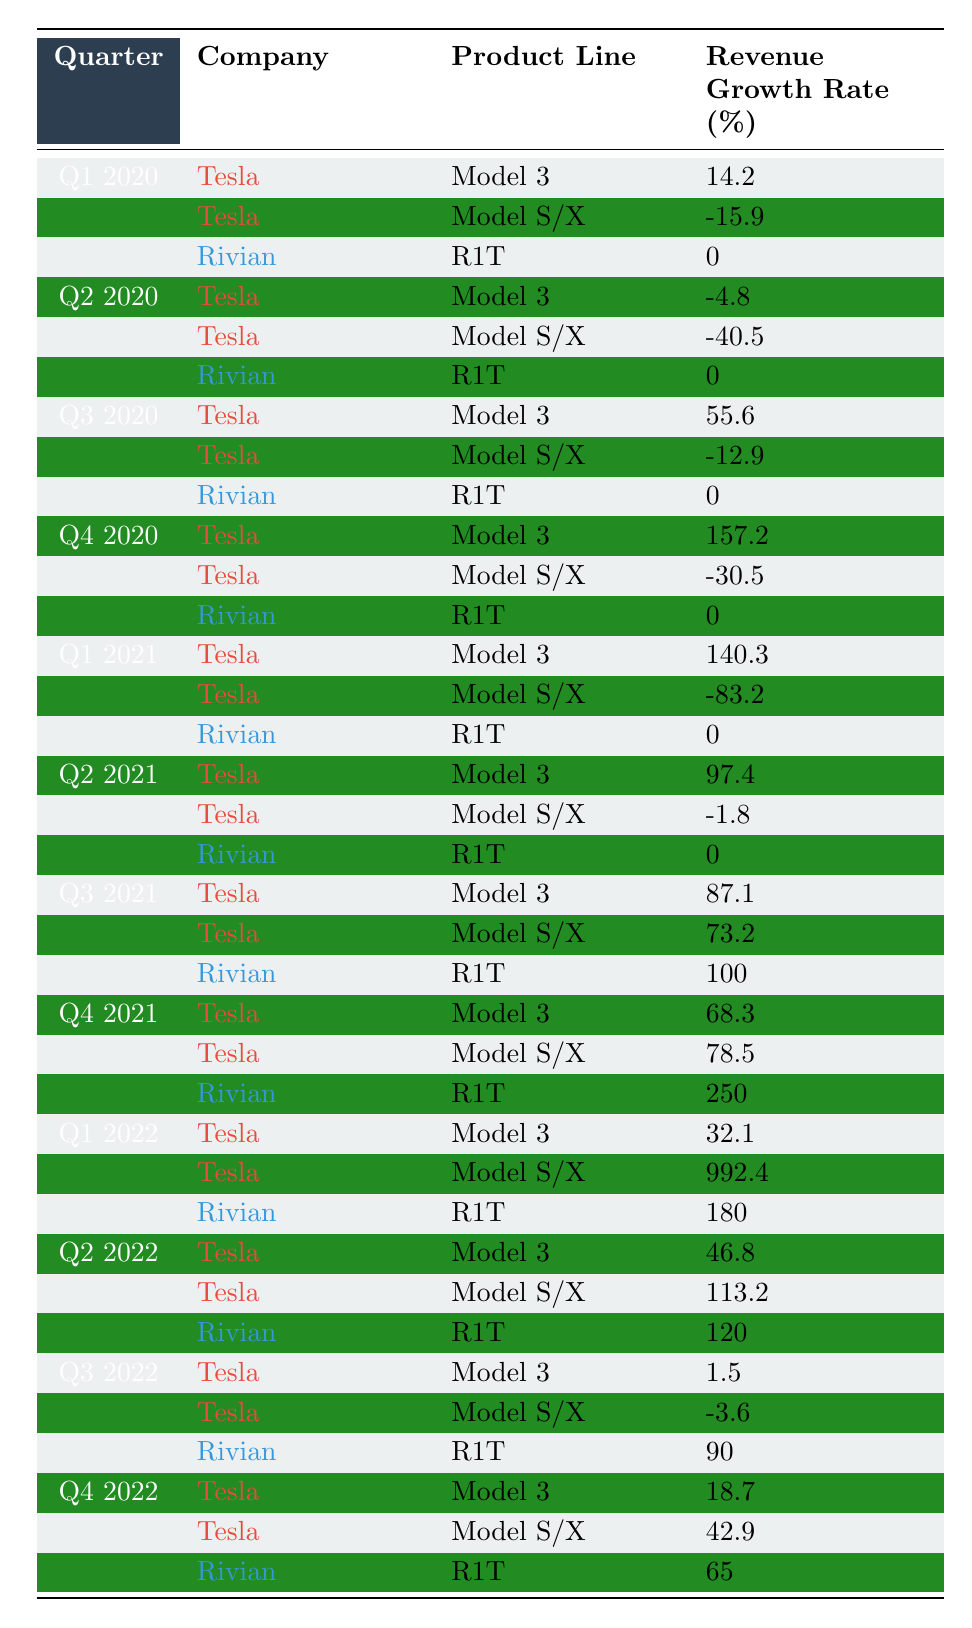What was the revenue growth rate for Tesla's Model 3 in Q4 2020? The table shows that in Q4 2020, Tesla's Model 3 had a revenue growth rate of 157.2% listed directly under that quarter and product line.
Answer: 157.2% What were the revenue growth rates for Rivian's R1T across all quarters? By scanning the table for Rivian's R1T, the growth rates are found: 0% in Q1 2020, Q2 2020, Q3 2020, and for subsequent quarters, 0% in Q1 2021 and Q2 2021, 100% in Q3 2021, 250% in Q4 2021, 180% in Q1 2022, 120% in Q2 2022, 90% in Q3 2022, and 65% in Q4 2022.
Answer: 0%, 0%, 0%, 0%, 100%, 250%, 180%, 120%, 90%, 65% What was Tesla's average revenue growth rate for Model S/X in 2021? The growth rates for Model S/X in 2021 are: -83.2% in Q1, -1.8% in Q2, 73.2% in Q3, and 78.5% in Q4. Adding these gives a total of 67.7%. Dividing by the number of quarters (4), the average is 67.7% / 4 = 16.925%.
Answer: 16.925% Did Rivian's R1T ever achieve a positive revenue growth rate? The data shows that Rivian's R1T had a growth rate of 100% in Q3 2021 and 250% in Q4 2021, indicating it did achieve positive growth at those points.
Answer: Yes Which product line for Tesla had the highest revenue growth rate in Q1 2022? Looking at Q1 2022, Tesla’s Model S/X had a remarkable revenue growth rate of 992.4%, which is noted as the highest growth rate in that quarter.
Answer: 992.4% What is the total revenue growth rate for Tesla's Model 3 over the entire period? To determine the total growth rate for Model 3, all the individual growth rates from Q1 2020 to Q4 2022 must be summed: 14.2 + (-4.8) + 55.6 + 157.2 + 140.3 + 97.4 + 87.1 + 68.3 + 32.1 + 46.8 + 1.5 + 18.7 = 499.8%. Summarizing all these yields 499.8% over the period.
Answer: 499.8% How many quarters did Tesla’s Model S/X report negative growth rates? Referring to the table, Model S/X has negative growth rates of -15.9% in Q1 2020, -40.5% in Q2 2020, -83.2% in Q1 2021, and -1.8% in Q2 2021, totaling 4 quarters with negative growth.
Answer: 4 quarters Which company's product line had the lowest growth rate in Q2 2020? In the second quarter of 2020, Tesla's Model S/X had the lowest growth rate at -40.5%, which is noted in the table compared to the other product lines.
Answer: Tesla's Model S/X What pattern can be observed for Tesla's Model 3 revenue growth rates throughout 2020? The growth rates for Tesla's Model 3 in 2020 showed significant fluctuations: starting with positive growth in Q1 (14.2%), a downturn in Q2 (-4.8%), then a substantial increase in Q3 (55.6%) and Q4 (157.2%), indicating an overall upward trend after a brief dip.
Answer: Fluctuating with overall upward trend What is the difference between the highest and lowest revenue growth rates for Rivian's R1T in 2021? In 2021, Rivian's R1T growth rates noted are 0% for Q1, Q2, and Q4 with 100% in Q3 and 250% in Q4, which means the highest rate (250%) minus the lowest (0%) gives a difference of 250%.
Answer: 250% 